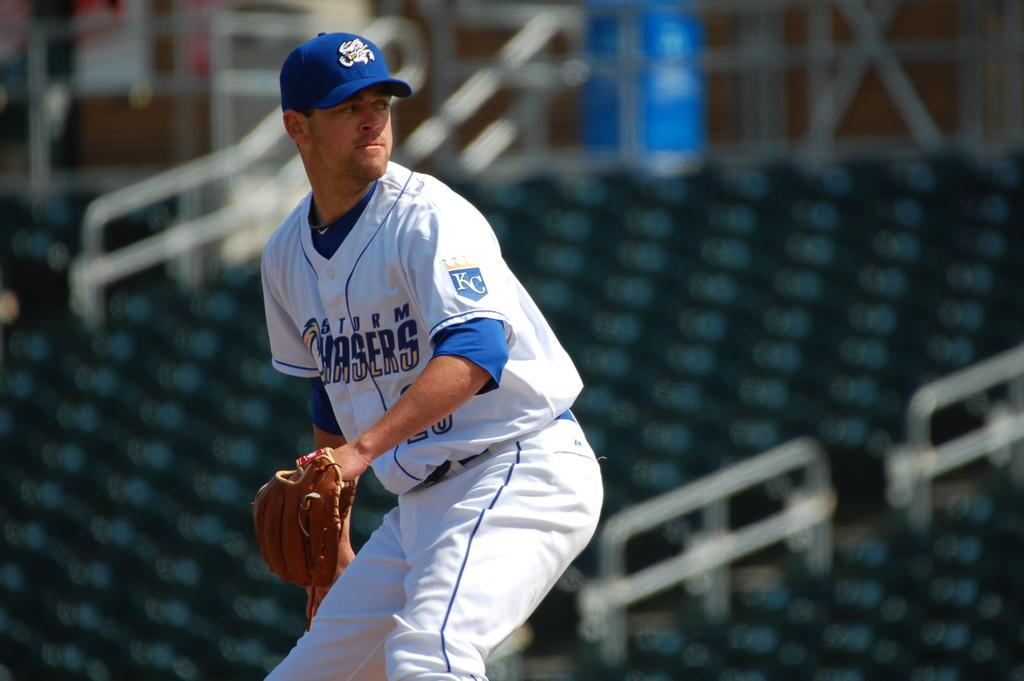<image>
Describe the image concisely. A baseball player wearing a jersey depicting the Storm Chasers team name. 